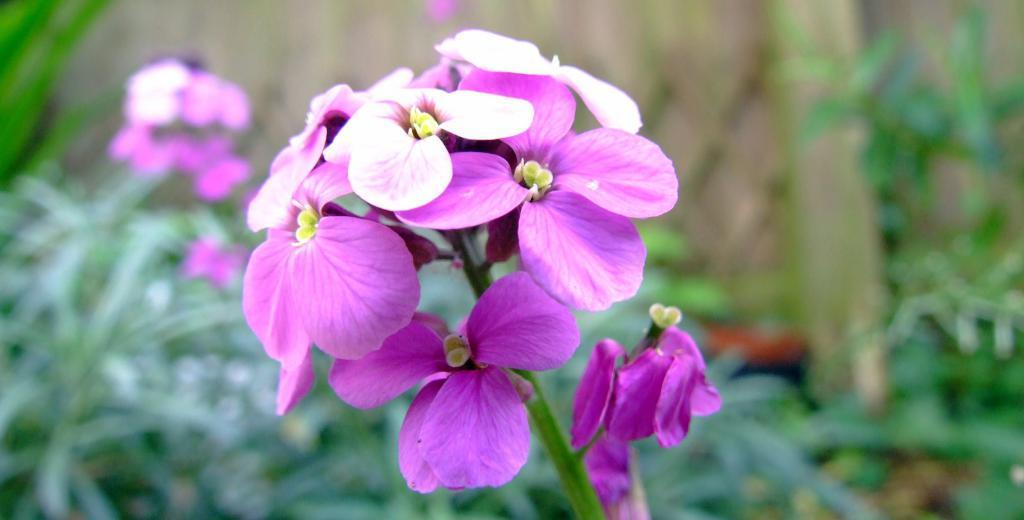Could you give a brief overview of what you see in this image? Here I can see few flower plants. The flowers are in pink and white colors. The background is blurred. 